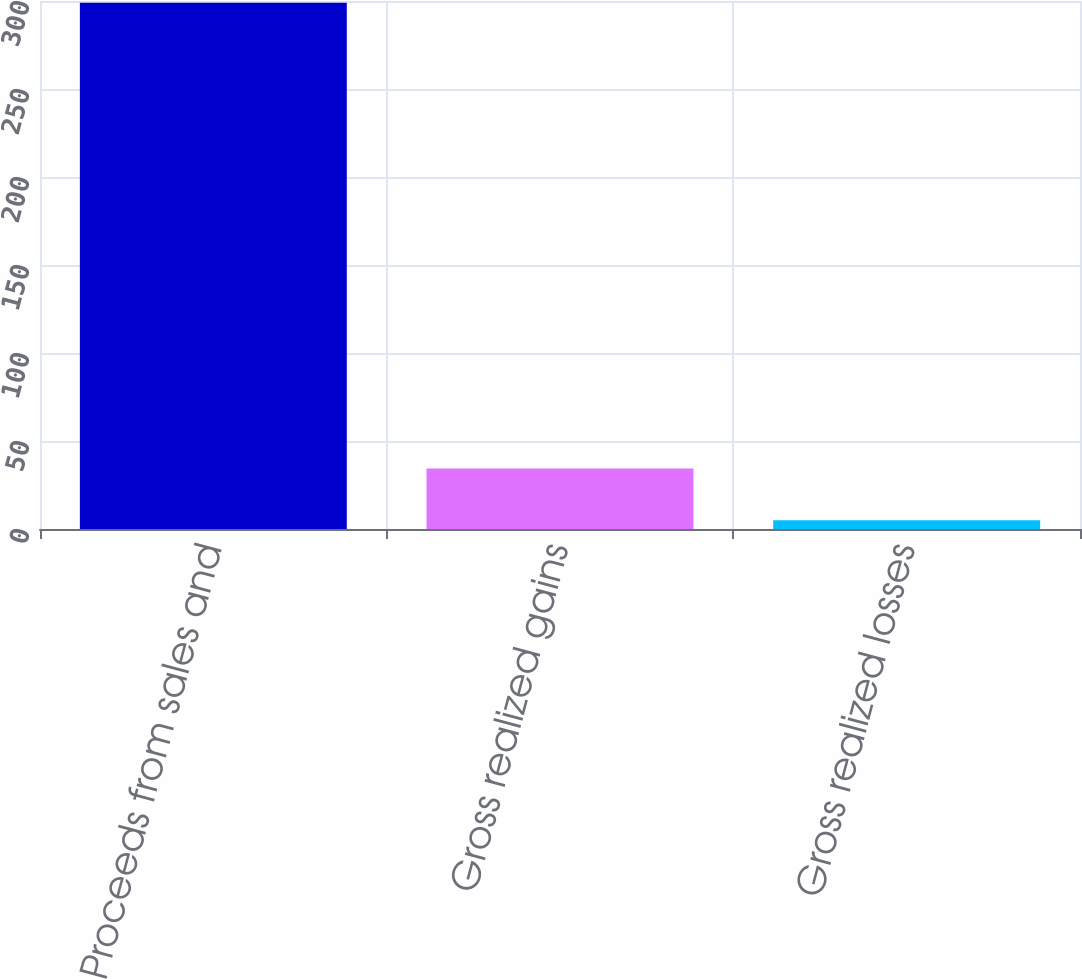Convert chart to OTSL. <chart><loc_0><loc_0><loc_500><loc_500><bar_chart><fcel>Proceeds from sales and<fcel>Gross realized gains<fcel>Gross realized losses<nl><fcel>299<fcel>34.4<fcel>5<nl></chart> 